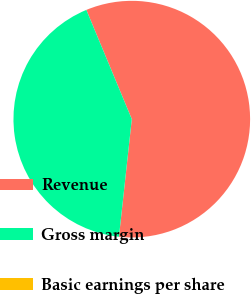Convert chart. <chart><loc_0><loc_0><loc_500><loc_500><pie_chart><fcel>Revenue<fcel>Gross margin<fcel>Basic earnings per share<nl><fcel>58.0%<fcel>41.99%<fcel>0.0%<nl></chart> 